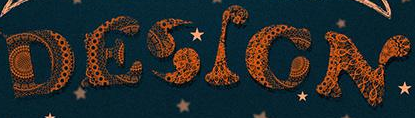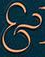Identify the words shown in these images in order, separated by a semicolon. DESIGN; & 